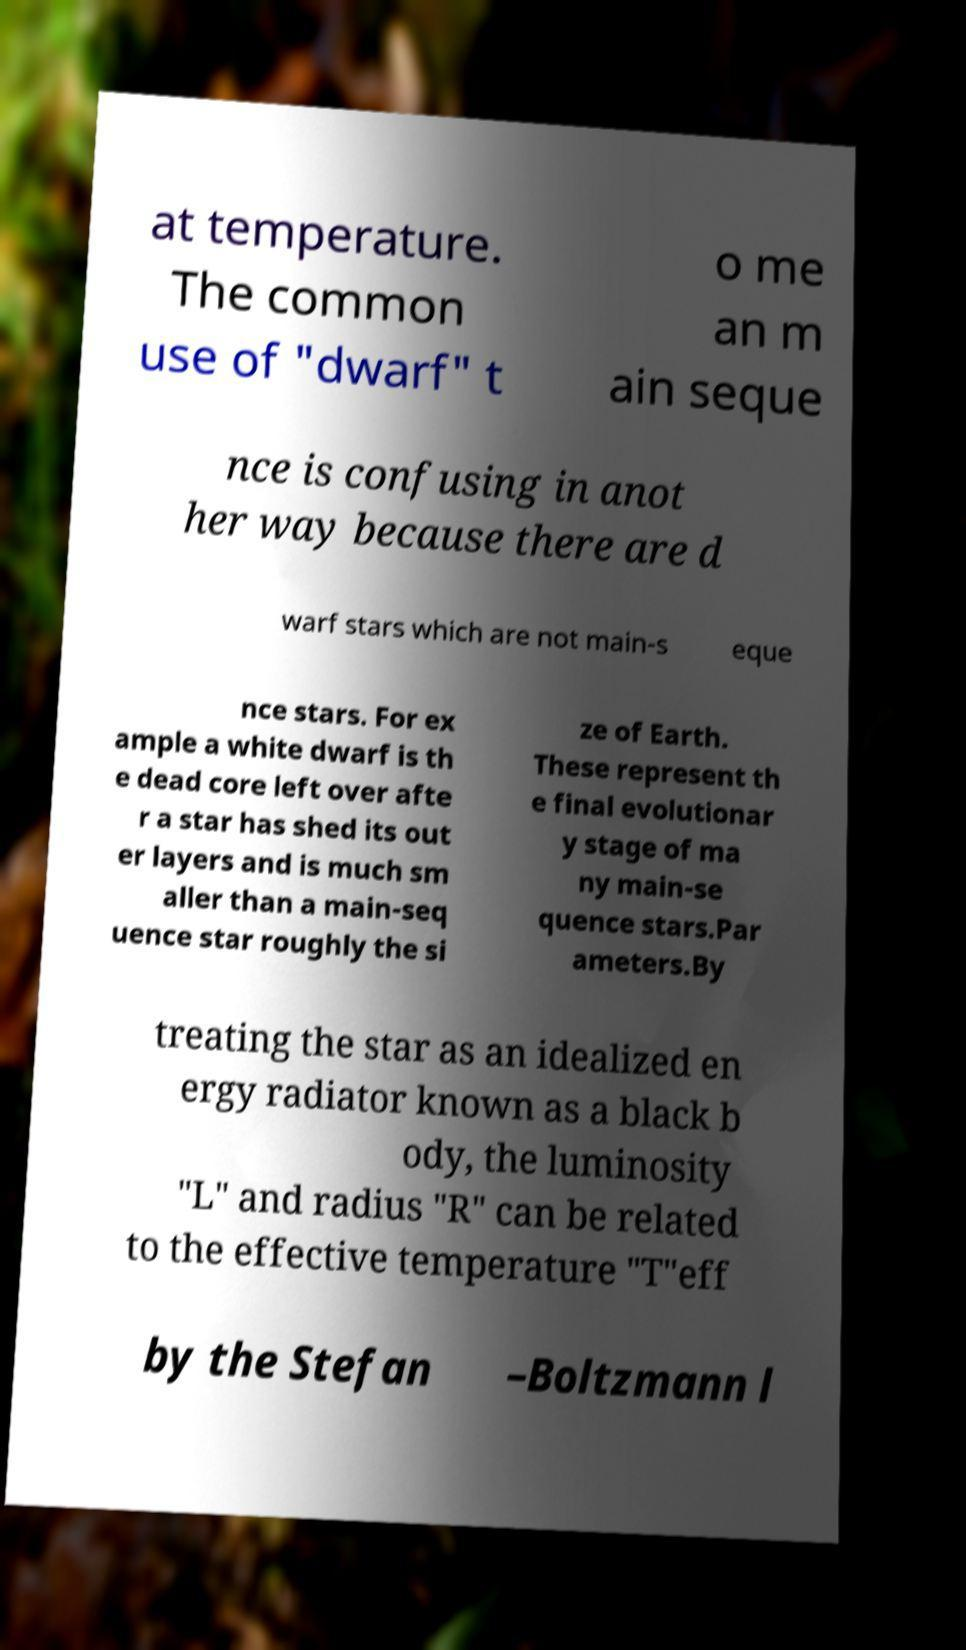Can you accurately transcribe the text from the provided image for me? at temperature. The common use of "dwarf" t o me an m ain seque nce is confusing in anot her way because there are d warf stars which are not main-s eque nce stars. For ex ample a white dwarf is th e dead core left over afte r a star has shed its out er layers and is much sm aller than a main-seq uence star roughly the si ze of Earth. These represent th e final evolutionar y stage of ma ny main-se quence stars.Par ameters.By treating the star as an idealized en ergy radiator known as a black b ody, the luminosity "L" and radius "R" can be related to the effective temperature "T"eff by the Stefan –Boltzmann l 